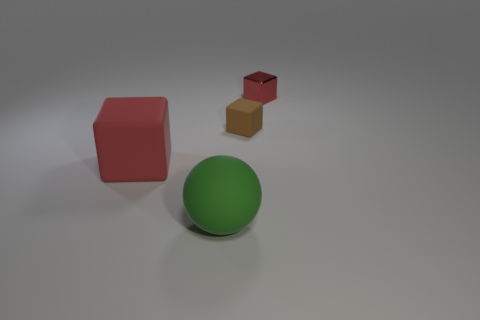Is the size of the red object that is to the left of the metallic object the same as the brown cube that is in front of the small red metallic thing?
Your response must be concise. No. What is the size of the red rubber thing?
Provide a succinct answer. Large. How many other objects are the same color as the small matte cube?
Give a very brief answer. 0. There is a thing in front of the matte cube in front of the tiny block that is in front of the small red block; what is its size?
Provide a short and direct response. Large. The tiny rubber thing is what shape?
Your answer should be very brief. Cube. How many other objects are there of the same material as the green sphere?
Your answer should be very brief. 2. What size is the other brown thing that is the same shape as the shiny object?
Provide a succinct answer. Small. What is the material of the small brown thing behind the large rubber thing that is to the right of the red object that is left of the small red metal thing?
Ensure brevity in your answer.  Rubber. Are any gray balls visible?
Give a very brief answer. No. Is the color of the tiny shiny thing the same as the large cube that is in front of the small shiny object?
Keep it short and to the point. Yes. 